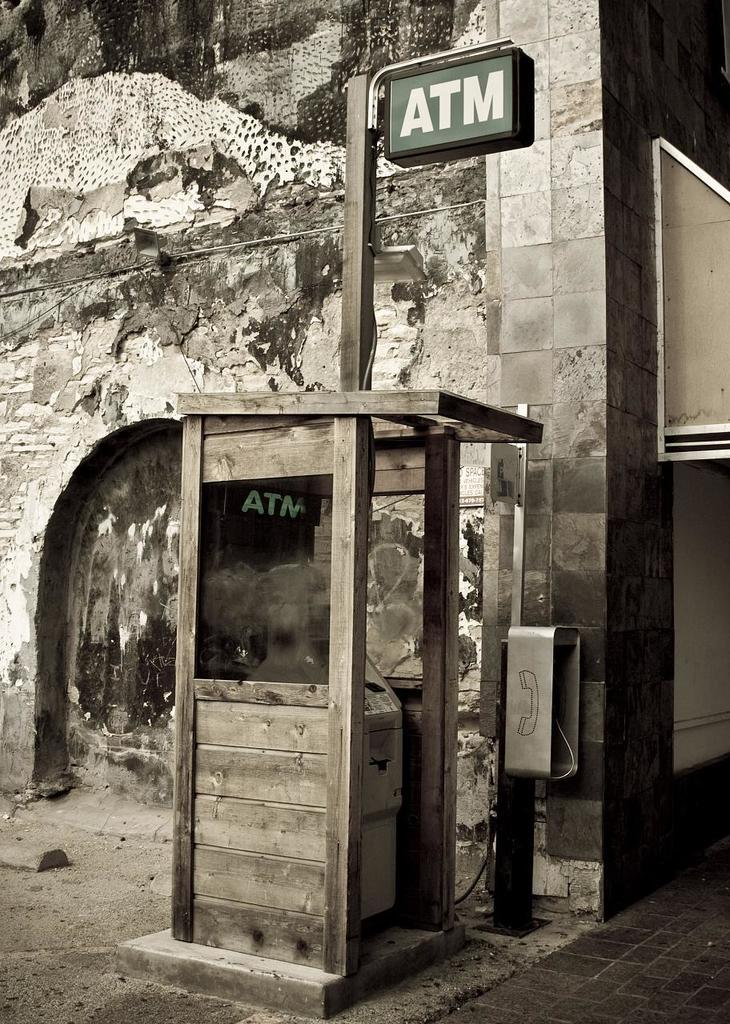What is the main object in the image? There is a machine in the image. What else can be seen in the image besides the machine? There is a booth, a wooden pole, a name board, a telephone, a wall, and a floor in the image. Can you describe the booth in the image? The booth is a structure that might be used for shelter or protection. What is the purpose of the name board in the image? The name board is likely used to display information or identify the location. How does the machine reason in the image? The machine does not reason in the image, as it is an inanimate object. Can you see a boot hanging on the wooden pole in the image? There is no boot present in the image. Is there an umbrella visible in the image? There is no umbrella present in the image. 